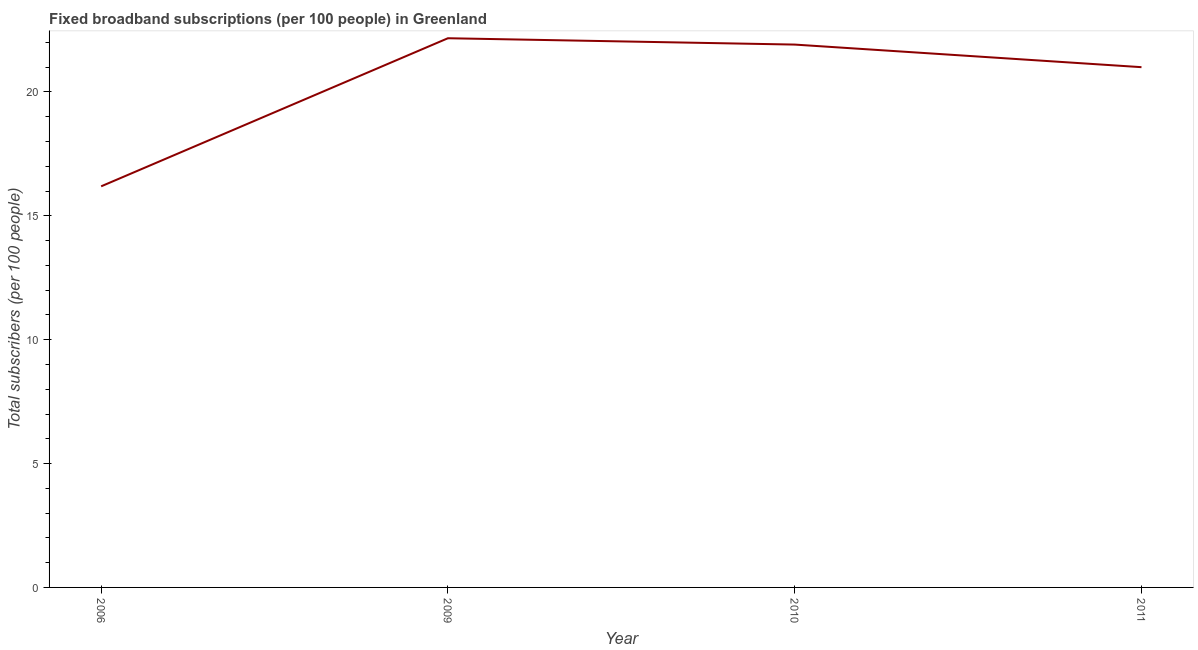What is the total number of fixed broadband subscriptions in 2009?
Give a very brief answer. 22.17. Across all years, what is the maximum total number of fixed broadband subscriptions?
Offer a terse response. 22.17. Across all years, what is the minimum total number of fixed broadband subscriptions?
Offer a very short reply. 16.19. In which year was the total number of fixed broadband subscriptions maximum?
Your answer should be compact. 2009. What is the sum of the total number of fixed broadband subscriptions?
Your answer should be very brief. 81.27. What is the difference between the total number of fixed broadband subscriptions in 2006 and 2009?
Provide a short and direct response. -5.98. What is the average total number of fixed broadband subscriptions per year?
Offer a very short reply. 20.32. What is the median total number of fixed broadband subscriptions?
Your answer should be compact. 21.46. Do a majority of the years between 2009 and 2010 (inclusive) have total number of fixed broadband subscriptions greater than 11 ?
Your answer should be compact. Yes. What is the ratio of the total number of fixed broadband subscriptions in 2006 to that in 2009?
Give a very brief answer. 0.73. Is the difference between the total number of fixed broadband subscriptions in 2010 and 2011 greater than the difference between any two years?
Give a very brief answer. No. What is the difference between the highest and the second highest total number of fixed broadband subscriptions?
Make the answer very short. 0.26. Is the sum of the total number of fixed broadband subscriptions in 2006 and 2009 greater than the maximum total number of fixed broadband subscriptions across all years?
Keep it short and to the point. Yes. What is the difference between the highest and the lowest total number of fixed broadband subscriptions?
Make the answer very short. 5.98. How many lines are there?
Offer a terse response. 1. Does the graph contain any zero values?
Offer a very short reply. No. Does the graph contain grids?
Offer a terse response. No. What is the title of the graph?
Your response must be concise. Fixed broadband subscriptions (per 100 people) in Greenland. What is the label or title of the X-axis?
Keep it short and to the point. Year. What is the label or title of the Y-axis?
Ensure brevity in your answer.  Total subscribers (per 100 people). What is the Total subscribers (per 100 people) of 2006?
Offer a very short reply. 16.19. What is the Total subscribers (per 100 people) in 2009?
Offer a very short reply. 22.17. What is the Total subscribers (per 100 people) in 2010?
Your answer should be compact. 21.91. What is the Total subscribers (per 100 people) in 2011?
Your answer should be very brief. 21. What is the difference between the Total subscribers (per 100 people) in 2006 and 2009?
Ensure brevity in your answer.  -5.98. What is the difference between the Total subscribers (per 100 people) in 2006 and 2010?
Offer a terse response. -5.72. What is the difference between the Total subscribers (per 100 people) in 2006 and 2011?
Make the answer very short. -4.81. What is the difference between the Total subscribers (per 100 people) in 2009 and 2010?
Your answer should be very brief. 0.26. What is the difference between the Total subscribers (per 100 people) in 2009 and 2011?
Provide a short and direct response. 1.17. What is the difference between the Total subscribers (per 100 people) in 2010 and 2011?
Your answer should be compact. 0.91. What is the ratio of the Total subscribers (per 100 people) in 2006 to that in 2009?
Make the answer very short. 0.73. What is the ratio of the Total subscribers (per 100 people) in 2006 to that in 2010?
Offer a terse response. 0.74. What is the ratio of the Total subscribers (per 100 people) in 2006 to that in 2011?
Your answer should be compact. 0.77. What is the ratio of the Total subscribers (per 100 people) in 2009 to that in 2011?
Provide a succinct answer. 1.06. What is the ratio of the Total subscribers (per 100 people) in 2010 to that in 2011?
Provide a succinct answer. 1.04. 